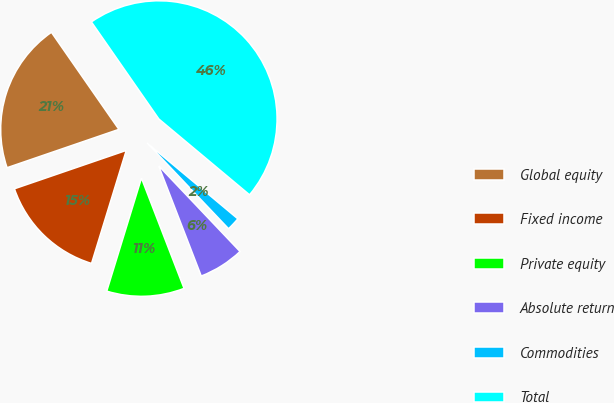Convert chart. <chart><loc_0><loc_0><loc_500><loc_500><pie_chart><fcel>Global equity<fcel>Fixed income<fcel>Private equity<fcel>Absolute return<fcel>Commodities<fcel>Total<nl><fcel>20.59%<fcel>15.0%<fcel>10.61%<fcel>6.22%<fcel>1.83%<fcel>45.75%<nl></chart> 